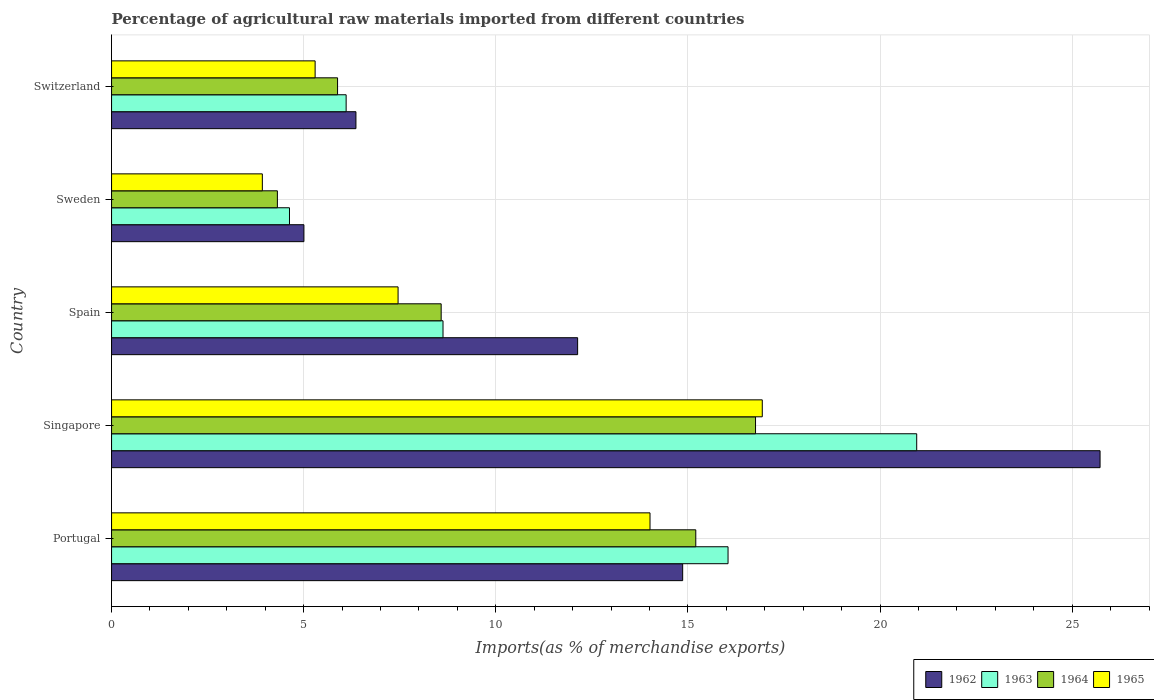In how many cases, is the number of bars for a given country not equal to the number of legend labels?
Ensure brevity in your answer.  0. What is the percentage of imports to different countries in 1965 in Portugal?
Provide a short and direct response. 14.01. Across all countries, what is the maximum percentage of imports to different countries in 1963?
Your response must be concise. 20.95. Across all countries, what is the minimum percentage of imports to different countries in 1965?
Offer a very short reply. 3.92. In which country was the percentage of imports to different countries in 1963 maximum?
Give a very brief answer. Singapore. In which country was the percentage of imports to different countries in 1963 minimum?
Your response must be concise. Sweden. What is the total percentage of imports to different countries in 1962 in the graph?
Make the answer very short. 64.08. What is the difference between the percentage of imports to different countries in 1963 in Portugal and that in Switzerland?
Offer a very short reply. 9.94. What is the difference between the percentage of imports to different countries in 1965 in Switzerland and the percentage of imports to different countries in 1963 in Portugal?
Your answer should be very brief. -10.75. What is the average percentage of imports to different countries in 1962 per country?
Provide a short and direct response. 12.82. What is the difference between the percentage of imports to different countries in 1962 and percentage of imports to different countries in 1963 in Spain?
Give a very brief answer. 3.5. In how many countries, is the percentage of imports to different countries in 1964 greater than 19 %?
Offer a very short reply. 0. What is the ratio of the percentage of imports to different countries in 1963 in Spain to that in Sweden?
Give a very brief answer. 1.86. Is the percentage of imports to different countries in 1965 in Sweden less than that in Switzerland?
Provide a succinct answer. Yes. Is the difference between the percentage of imports to different countries in 1962 in Portugal and Singapore greater than the difference between the percentage of imports to different countries in 1963 in Portugal and Singapore?
Your response must be concise. No. What is the difference between the highest and the second highest percentage of imports to different countries in 1965?
Your answer should be very brief. 2.92. What is the difference between the highest and the lowest percentage of imports to different countries in 1964?
Ensure brevity in your answer.  12.44. In how many countries, is the percentage of imports to different countries in 1964 greater than the average percentage of imports to different countries in 1964 taken over all countries?
Make the answer very short. 2. Is the sum of the percentage of imports to different countries in 1965 in Portugal and Singapore greater than the maximum percentage of imports to different countries in 1963 across all countries?
Your answer should be compact. Yes. What does the 3rd bar from the top in Spain represents?
Provide a succinct answer. 1963. What does the 4th bar from the bottom in Switzerland represents?
Give a very brief answer. 1965. Is it the case that in every country, the sum of the percentage of imports to different countries in 1964 and percentage of imports to different countries in 1962 is greater than the percentage of imports to different countries in 1965?
Your answer should be very brief. Yes. How many bars are there?
Make the answer very short. 20. How many countries are there in the graph?
Your answer should be very brief. 5. Are the values on the major ticks of X-axis written in scientific E-notation?
Give a very brief answer. No. Does the graph contain any zero values?
Your answer should be compact. No. How are the legend labels stacked?
Offer a very short reply. Horizontal. What is the title of the graph?
Ensure brevity in your answer.  Percentage of agricultural raw materials imported from different countries. Does "1985" appear as one of the legend labels in the graph?
Provide a short and direct response. No. What is the label or title of the X-axis?
Your answer should be very brief. Imports(as % of merchandise exports). What is the label or title of the Y-axis?
Keep it short and to the point. Country. What is the Imports(as % of merchandise exports) of 1962 in Portugal?
Offer a very short reply. 14.86. What is the Imports(as % of merchandise exports) of 1963 in Portugal?
Provide a short and direct response. 16.04. What is the Imports(as % of merchandise exports) of 1964 in Portugal?
Give a very brief answer. 15.2. What is the Imports(as % of merchandise exports) in 1965 in Portugal?
Your answer should be compact. 14.01. What is the Imports(as % of merchandise exports) of 1962 in Singapore?
Ensure brevity in your answer.  25.73. What is the Imports(as % of merchandise exports) in 1963 in Singapore?
Make the answer very short. 20.95. What is the Imports(as % of merchandise exports) in 1964 in Singapore?
Provide a succinct answer. 16.76. What is the Imports(as % of merchandise exports) in 1965 in Singapore?
Make the answer very short. 16.93. What is the Imports(as % of merchandise exports) of 1962 in Spain?
Your response must be concise. 12.13. What is the Imports(as % of merchandise exports) in 1963 in Spain?
Provide a succinct answer. 8.63. What is the Imports(as % of merchandise exports) in 1964 in Spain?
Your answer should be compact. 8.58. What is the Imports(as % of merchandise exports) in 1965 in Spain?
Make the answer very short. 7.46. What is the Imports(as % of merchandise exports) of 1962 in Sweden?
Offer a very short reply. 5.01. What is the Imports(as % of merchandise exports) in 1963 in Sweden?
Offer a very short reply. 4.63. What is the Imports(as % of merchandise exports) of 1964 in Sweden?
Offer a terse response. 4.32. What is the Imports(as % of merchandise exports) of 1965 in Sweden?
Offer a terse response. 3.92. What is the Imports(as % of merchandise exports) in 1962 in Switzerland?
Keep it short and to the point. 6.36. What is the Imports(as % of merchandise exports) in 1963 in Switzerland?
Provide a succinct answer. 6.1. What is the Imports(as % of merchandise exports) of 1964 in Switzerland?
Give a very brief answer. 5.88. What is the Imports(as % of merchandise exports) in 1965 in Switzerland?
Make the answer very short. 5.3. Across all countries, what is the maximum Imports(as % of merchandise exports) of 1962?
Your answer should be compact. 25.73. Across all countries, what is the maximum Imports(as % of merchandise exports) in 1963?
Give a very brief answer. 20.95. Across all countries, what is the maximum Imports(as % of merchandise exports) of 1964?
Offer a very short reply. 16.76. Across all countries, what is the maximum Imports(as % of merchandise exports) in 1965?
Make the answer very short. 16.93. Across all countries, what is the minimum Imports(as % of merchandise exports) in 1962?
Keep it short and to the point. 5.01. Across all countries, what is the minimum Imports(as % of merchandise exports) in 1963?
Keep it short and to the point. 4.63. Across all countries, what is the minimum Imports(as % of merchandise exports) of 1964?
Your answer should be very brief. 4.32. Across all countries, what is the minimum Imports(as % of merchandise exports) in 1965?
Your answer should be very brief. 3.92. What is the total Imports(as % of merchandise exports) of 1962 in the graph?
Make the answer very short. 64.08. What is the total Imports(as % of merchandise exports) in 1963 in the graph?
Offer a very short reply. 56.36. What is the total Imports(as % of merchandise exports) of 1964 in the graph?
Offer a terse response. 50.74. What is the total Imports(as % of merchandise exports) in 1965 in the graph?
Provide a succinct answer. 47.63. What is the difference between the Imports(as % of merchandise exports) of 1962 in Portugal and that in Singapore?
Provide a succinct answer. -10.86. What is the difference between the Imports(as % of merchandise exports) in 1963 in Portugal and that in Singapore?
Your response must be concise. -4.91. What is the difference between the Imports(as % of merchandise exports) in 1964 in Portugal and that in Singapore?
Provide a short and direct response. -1.55. What is the difference between the Imports(as % of merchandise exports) of 1965 in Portugal and that in Singapore?
Your answer should be compact. -2.92. What is the difference between the Imports(as % of merchandise exports) in 1962 in Portugal and that in Spain?
Provide a short and direct response. 2.73. What is the difference between the Imports(as % of merchandise exports) in 1963 in Portugal and that in Spain?
Ensure brevity in your answer.  7.42. What is the difference between the Imports(as % of merchandise exports) in 1964 in Portugal and that in Spain?
Keep it short and to the point. 6.63. What is the difference between the Imports(as % of merchandise exports) of 1965 in Portugal and that in Spain?
Your response must be concise. 6.56. What is the difference between the Imports(as % of merchandise exports) in 1962 in Portugal and that in Sweden?
Your answer should be very brief. 9.86. What is the difference between the Imports(as % of merchandise exports) in 1963 in Portugal and that in Sweden?
Give a very brief answer. 11.41. What is the difference between the Imports(as % of merchandise exports) of 1964 in Portugal and that in Sweden?
Your answer should be compact. 10.89. What is the difference between the Imports(as % of merchandise exports) in 1965 in Portugal and that in Sweden?
Offer a terse response. 10.09. What is the difference between the Imports(as % of merchandise exports) of 1962 in Portugal and that in Switzerland?
Provide a short and direct response. 8.5. What is the difference between the Imports(as % of merchandise exports) of 1963 in Portugal and that in Switzerland?
Your answer should be compact. 9.94. What is the difference between the Imports(as % of merchandise exports) in 1964 in Portugal and that in Switzerland?
Offer a terse response. 9.32. What is the difference between the Imports(as % of merchandise exports) of 1965 in Portugal and that in Switzerland?
Give a very brief answer. 8.72. What is the difference between the Imports(as % of merchandise exports) in 1962 in Singapore and that in Spain?
Provide a short and direct response. 13.6. What is the difference between the Imports(as % of merchandise exports) in 1963 in Singapore and that in Spain?
Your answer should be compact. 12.33. What is the difference between the Imports(as % of merchandise exports) of 1964 in Singapore and that in Spain?
Your answer should be compact. 8.18. What is the difference between the Imports(as % of merchandise exports) in 1965 in Singapore and that in Spain?
Keep it short and to the point. 9.48. What is the difference between the Imports(as % of merchandise exports) in 1962 in Singapore and that in Sweden?
Keep it short and to the point. 20.72. What is the difference between the Imports(as % of merchandise exports) in 1963 in Singapore and that in Sweden?
Make the answer very short. 16.32. What is the difference between the Imports(as % of merchandise exports) of 1964 in Singapore and that in Sweden?
Provide a succinct answer. 12.44. What is the difference between the Imports(as % of merchandise exports) of 1965 in Singapore and that in Sweden?
Make the answer very short. 13.01. What is the difference between the Imports(as % of merchandise exports) of 1962 in Singapore and that in Switzerland?
Make the answer very short. 19.37. What is the difference between the Imports(as % of merchandise exports) in 1963 in Singapore and that in Switzerland?
Offer a terse response. 14.85. What is the difference between the Imports(as % of merchandise exports) in 1964 in Singapore and that in Switzerland?
Ensure brevity in your answer.  10.88. What is the difference between the Imports(as % of merchandise exports) in 1965 in Singapore and that in Switzerland?
Keep it short and to the point. 11.64. What is the difference between the Imports(as % of merchandise exports) of 1962 in Spain and that in Sweden?
Ensure brevity in your answer.  7.12. What is the difference between the Imports(as % of merchandise exports) of 1963 in Spain and that in Sweden?
Offer a very short reply. 4. What is the difference between the Imports(as % of merchandise exports) in 1964 in Spain and that in Sweden?
Ensure brevity in your answer.  4.26. What is the difference between the Imports(as % of merchandise exports) in 1965 in Spain and that in Sweden?
Your answer should be very brief. 3.53. What is the difference between the Imports(as % of merchandise exports) of 1962 in Spain and that in Switzerland?
Keep it short and to the point. 5.77. What is the difference between the Imports(as % of merchandise exports) of 1963 in Spain and that in Switzerland?
Provide a succinct answer. 2.52. What is the difference between the Imports(as % of merchandise exports) in 1964 in Spain and that in Switzerland?
Make the answer very short. 2.7. What is the difference between the Imports(as % of merchandise exports) of 1965 in Spain and that in Switzerland?
Make the answer very short. 2.16. What is the difference between the Imports(as % of merchandise exports) of 1962 in Sweden and that in Switzerland?
Offer a very short reply. -1.35. What is the difference between the Imports(as % of merchandise exports) of 1963 in Sweden and that in Switzerland?
Your answer should be compact. -1.47. What is the difference between the Imports(as % of merchandise exports) of 1964 in Sweden and that in Switzerland?
Your response must be concise. -1.57. What is the difference between the Imports(as % of merchandise exports) of 1965 in Sweden and that in Switzerland?
Offer a very short reply. -1.37. What is the difference between the Imports(as % of merchandise exports) of 1962 in Portugal and the Imports(as % of merchandise exports) of 1963 in Singapore?
Make the answer very short. -6.09. What is the difference between the Imports(as % of merchandise exports) of 1962 in Portugal and the Imports(as % of merchandise exports) of 1964 in Singapore?
Your response must be concise. -1.9. What is the difference between the Imports(as % of merchandise exports) of 1962 in Portugal and the Imports(as % of merchandise exports) of 1965 in Singapore?
Ensure brevity in your answer.  -2.07. What is the difference between the Imports(as % of merchandise exports) in 1963 in Portugal and the Imports(as % of merchandise exports) in 1964 in Singapore?
Your answer should be compact. -0.72. What is the difference between the Imports(as % of merchandise exports) in 1963 in Portugal and the Imports(as % of merchandise exports) in 1965 in Singapore?
Your answer should be very brief. -0.89. What is the difference between the Imports(as % of merchandise exports) of 1964 in Portugal and the Imports(as % of merchandise exports) of 1965 in Singapore?
Give a very brief answer. -1.73. What is the difference between the Imports(as % of merchandise exports) in 1962 in Portugal and the Imports(as % of merchandise exports) in 1963 in Spain?
Offer a very short reply. 6.24. What is the difference between the Imports(as % of merchandise exports) in 1962 in Portugal and the Imports(as % of merchandise exports) in 1964 in Spain?
Keep it short and to the point. 6.28. What is the difference between the Imports(as % of merchandise exports) of 1962 in Portugal and the Imports(as % of merchandise exports) of 1965 in Spain?
Provide a succinct answer. 7.41. What is the difference between the Imports(as % of merchandise exports) of 1963 in Portugal and the Imports(as % of merchandise exports) of 1964 in Spain?
Ensure brevity in your answer.  7.47. What is the difference between the Imports(as % of merchandise exports) in 1963 in Portugal and the Imports(as % of merchandise exports) in 1965 in Spain?
Your response must be concise. 8.59. What is the difference between the Imports(as % of merchandise exports) in 1964 in Portugal and the Imports(as % of merchandise exports) in 1965 in Spain?
Your answer should be compact. 7.75. What is the difference between the Imports(as % of merchandise exports) in 1962 in Portugal and the Imports(as % of merchandise exports) in 1963 in Sweden?
Provide a succinct answer. 10.23. What is the difference between the Imports(as % of merchandise exports) of 1962 in Portugal and the Imports(as % of merchandise exports) of 1964 in Sweden?
Offer a terse response. 10.55. What is the difference between the Imports(as % of merchandise exports) of 1962 in Portugal and the Imports(as % of merchandise exports) of 1965 in Sweden?
Offer a very short reply. 10.94. What is the difference between the Imports(as % of merchandise exports) in 1963 in Portugal and the Imports(as % of merchandise exports) in 1964 in Sweden?
Offer a very short reply. 11.73. What is the difference between the Imports(as % of merchandise exports) of 1963 in Portugal and the Imports(as % of merchandise exports) of 1965 in Sweden?
Provide a short and direct response. 12.12. What is the difference between the Imports(as % of merchandise exports) of 1964 in Portugal and the Imports(as % of merchandise exports) of 1965 in Sweden?
Give a very brief answer. 11.28. What is the difference between the Imports(as % of merchandise exports) of 1962 in Portugal and the Imports(as % of merchandise exports) of 1963 in Switzerland?
Your answer should be compact. 8.76. What is the difference between the Imports(as % of merchandise exports) of 1962 in Portugal and the Imports(as % of merchandise exports) of 1964 in Switzerland?
Ensure brevity in your answer.  8.98. What is the difference between the Imports(as % of merchandise exports) in 1962 in Portugal and the Imports(as % of merchandise exports) in 1965 in Switzerland?
Make the answer very short. 9.57. What is the difference between the Imports(as % of merchandise exports) of 1963 in Portugal and the Imports(as % of merchandise exports) of 1964 in Switzerland?
Your response must be concise. 10.16. What is the difference between the Imports(as % of merchandise exports) of 1963 in Portugal and the Imports(as % of merchandise exports) of 1965 in Switzerland?
Make the answer very short. 10.75. What is the difference between the Imports(as % of merchandise exports) in 1964 in Portugal and the Imports(as % of merchandise exports) in 1965 in Switzerland?
Provide a succinct answer. 9.91. What is the difference between the Imports(as % of merchandise exports) of 1962 in Singapore and the Imports(as % of merchandise exports) of 1963 in Spain?
Keep it short and to the point. 17.1. What is the difference between the Imports(as % of merchandise exports) in 1962 in Singapore and the Imports(as % of merchandise exports) in 1964 in Spain?
Give a very brief answer. 17.15. What is the difference between the Imports(as % of merchandise exports) of 1962 in Singapore and the Imports(as % of merchandise exports) of 1965 in Spain?
Ensure brevity in your answer.  18.27. What is the difference between the Imports(as % of merchandise exports) of 1963 in Singapore and the Imports(as % of merchandise exports) of 1964 in Spain?
Your response must be concise. 12.38. What is the difference between the Imports(as % of merchandise exports) of 1963 in Singapore and the Imports(as % of merchandise exports) of 1965 in Spain?
Give a very brief answer. 13.5. What is the difference between the Imports(as % of merchandise exports) in 1964 in Singapore and the Imports(as % of merchandise exports) in 1965 in Spain?
Make the answer very short. 9.3. What is the difference between the Imports(as % of merchandise exports) of 1962 in Singapore and the Imports(as % of merchandise exports) of 1963 in Sweden?
Your answer should be very brief. 21.09. What is the difference between the Imports(as % of merchandise exports) of 1962 in Singapore and the Imports(as % of merchandise exports) of 1964 in Sweden?
Offer a terse response. 21.41. What is the difference between the Imports(as % of merchandise exports) in 1962 in Singapore and the Imports(as % of merchandise exports) in 1965 in Sweden?
Give a very brief answer. 21.8. What is the difference between the Imports(as % of merchandise exports) in 1963 in Singapore and the Imports(as % of merchandise exports) in 1964 in Sweden?
Offer a terse response. 16.64. What is the difference between the Imports(as % of merchandise exports) of 1963 in Singapore and the Imports(as % of merchandise exports) of 1965 in Sweden?
Your response must be concise. 17.03. What is the difference between the Imports(as % of merchandise exports) of 1964 in Singapore and the Imports(as % of merchandise exports) of 1965 in Sweden?
Your response must be concise. 12.83. What is the difference between the Imports(as % of merchandise exports) in 1962 in Singapore and the Imports(as % of merchandise exports) in 1963 in Switzerland?
Give a very brief answer. 19.62. What is the difference between the Imports(as % of merchandise exports) of 1962 in Singapore and the Imports(as % of merchandise exports) of 1964 in Switzerland?
Your answer should be compact. 19.84. What is the difference between the Imports(as % of merchandise exports) in 1962 in Singapore and the Imports(as % of merchandise exports) in 1965 in Switzerland?
Your response must be concise. 20.43. What is the difference between the Imports(as % of merchandise exports) of 1963 in Singapore and the Imports(as % of merchandise exports) of 1964 in Switzerland?
Give a very brief answer. 15.07. What is the difference between the Imports(as % of merchandise exports) of 1963 in Singapore and the Imports(as % of merchandise exports) of 1965 in Switzerland?
Your answer should be compact. 15.66. What is the difference between the Imports(as % of merchandise exports) in 1964 in Singapore and the Imports(as % of merchandise exports) in 1965 in Switzerland?
Provide a short and direct response. 11.46. What is the difference between the Imports(as % of merchandise exports) of 1962 in Spain and the Imports(as % of merchandise exports) of 1963 in Sweden?
Give a very brief answer. 7.5. What is the difference between the Imports(as % of merchandise exports) of 1962 in Spain and the Imports(as % of merchandise exports) of 1964 in Sweden?
Provide a short and direct response. 7.81. What is the difference between the Imports(as % of merchandise exports) in 1962 in Spain and the Imports(as % of merchandise exports) in 1965 in Sweden?
Make the answer very short. 8.21. What is the difference between the Imports(as % of merchandise exports) of 1963 in Spain and the Imports(as % of merchandise exports) of 1964 in Sweden?
Provide a short and direct response. 4.31. What is the difference between the Imports(as % of merchandise exports) in 1963 in Spain and the Imports(as % of merchandise exports) in 1965 in Sweden?
Provide a succinct answer. 4.7. What is the difference between the Imports(as % of merchandise exports) in 1964 in Spain and the Imports(as % of merchandise exports) in 1965 in Sweden?
Give a very brief answer. 4.65. What is the difference between the Imports(as % of merchandise exports) in 1962 in Spain and the Imports(as % of merchandise exports) in 1963 in Switzerland?
Offer a terse response. 6.02. What is the difference between the Imports(as % of merchandise exports) in 1962 in Spain and the Imports(as % of merchandise exports) in 1964 in Switzerland?
Your answer should be compact. 6.25. What is the difference between the Imports(as % of merchandise exports) of 1962 in Spain and the Imports(as % of merchandise exports) of 1965 in Switzerland?
Provide a succinct answer. 6.83. What is the difference between the Imports(as % of merchandise exports) in 1963 in Spain and the Imports(as % of merchandise exports) in 1964 in Switzerland?
Give a very brief answer. 2.74. What is the difference between the Imports(as % of merchandise exports) of 1963 in Spain and the Imports(as % of merchandise exports) of 1965 in Switzerland?
Offer a terse response. 3.33. What is the difference between the Imports(as % of merchandise exports) in 1964 in Spain and the Imports(as % of merchandise exports) in 1965 in Switzerland?
Your answer should be compact. 3.28. What is the difference between the Imports(as % of merchandise exports) in 1962 in Sweden and the Imports(as % of merchandise exports) in 1963 in Switzerland?
Offer a very short reply. -1.1. What is the difference between the Imports(as % of merchandise exports) in 1962 in Sweden and the Imports(as % of merchandise exports) in 1964 in Switzerland?
Your answer should be very brief. -0.88. What is the difference between the Imports(as % of merchandise exports) in 1962 in Sweden and the Imports(as % of merchandise exports) in 1965 in Switzerland?
Offer a terse response. -0.29. What is the difference between the Imports(as % of merchandise exports) in 1963 in Sweden and the Imports(as % of merchandise exports) in 1964 in Switzerland?
Offer a very short reply. -1.25. What is the difference between the Imports(as % of merchandise exports) in 1963 in Sweden and the Imports(as % of merchandise exports) in 1965 in Switzerland?
Offer a terse response. -0.67. What is the difference between the Imports(as % of merchandise exports) in 1964 in Sweden and the Imports(as % of merchandise exports) in 1965 in Switzerland?
Your answer should be compact. -0.98. What is the average Imports(as % of merchandise exports) of 1962 per country?
Provide a succinct answer. 12.82. What is the average Imports(as % of merchandise exports) of 1963 per country?
Provide a succinct answer. 11.27. What is the average Imports(as % of merchandise exports) in 1964 per country?
Offer a terse response. 10.15. What is the average Imports(as % of merchandise exports) of 1965 per country?
Keep it short and to the point. 9.53. What is the difference between the Imports(as % of merchandise exports) in 1962 and Imports(as % of merchandise exports) in 1963 in Portugal?
Your answer should be compact. -1.18. What is the difference between the Imports(as % of merchandise exports) in 1962 and Imports(as % of merchandise exports) in 1964 in Portugal?
Give a very brief answer. -0.34. What is the difference between the Imports(as % of merchandise exports) of 1962 and Imports(as % of merchandise exports) of 1965 in Portugal?
Your answer should be very brief. 0.85. What is the difference between the Imports(as % of merchandise exports) in 1963 and Imports(as % of merchandise exports) in 1964 in Portugal?
Provide a succinct answer. 0.84. What is the difference between the Imports(as % of merchandise exports) of 1963 and Imports(as % of merchandise exports) of 1965 in Portugal?
Keep it short and to the point. 2.03. What is the difference between the Imports(as % of merchandise exports) of 1964 and Imports(as % of merchandise exports) of 1965 in Portugal?
Your answer should be compact. 1.19. What is the difference between the Imports(as % of merchandise exports) in 1962 and Imports(as % of merchandise exports) in 1963 in Singapore?
Offer a terse response. 4.77. What is the difference between the Imports(as % of merchandise exports) of 1962 and Imports(as % of merchandise exports) of 1964 in Singapore?
Keep it short and to the point. 8.97. What is the difference between the Imports(as % of merchandise exports) of 1962 and Imports(as % of merchandise exports) of 1965 in Singapore?
Your answer should be very brief. 8.79. What is the difference between the Imports(as % of merchandise exports) in 1963 and Imports(as % of merchandise exports) in 1964 in Singapore?
Your answer should be compact. 4.19. What is the difference between the Imports(as % of merchandise exports) of 1963 and Imports(as % of merchandise exports) of 1965 in Singapore?
Provide a short and direct response. 4.02. What is the difference between the Imports(as % of merchandise exports) of 1964 and Imports(as % of merchandise exports) of 1965 in Singapore?
Give a very brief answer. -0.18. What is the difference between the Imports(as % of merchandise exports) in 1962 and Imports(as % of merchandise exports) in 1963 in Spain?
Provide a succinct answer. 3.5. What is the difference between the Imports(as % of merchandise exports) of 1962 and Imports(as % of merchandise exports) of 1964 in Spain?
Offer a terse response. 3.55. What is the difference between the Imports(as % of merchandise exports) of 1962 and Imports(as % of merchandise exports) of 1965 in Spain?
Make the answer very short. 4.67. What is the difference between the Imports(as % of merchandise exports) in 1963 and Imports(as % of merchandise exports) in 1964 in Spain?
Ensure brevity in your answer.  0.05. What is the difference between the Imports(as % of merchandise exports) of 1963 and Imports(as % of merchandise exports) of 1965 in Spain?
Give a very brief answer. 1.17. What is the difference between the Imports(as % of merchandise exports) in 1964 and Imports(as % of merchandise exports) in 1965 in Spain?
Provide a succinct answer. 1.12. What is the difference between the Imports(as % of merchandise exports) in 1962 and Imports(as % of merchandise exports) in 1963 in Sweden?
Give a very brief answer. 0.38. What is the difference between the Imports(as % of merchandise exports) of 1962 and Imports(as % of merchandise exports) of 1964 in Sweden?
Your answer should be compact. 0.69. What is the difference between the Imports(as % of merchandise exports) in 1962 and Imports(as % of merchandise exports) in 1965 in Sweden?
Offer a very short reply. 1.08. What is the difference between the Imports(as % of merchandise exports) in 1963 and Imports(as % of merchandise exports) in 1964 in Sweden?
Your response must be concise. 0.31. What is the difference between the Imports(as % of merchandise exports) in 1963 and Imports(as % of merchandise exports) in 1965 in Sweden?
Keep it short and to the point. 0.71. What is the difference between the Imports(as % of merchandise exports) in 1964 and Imports(as % of merchandise exports) in 1965 in Sweden?
Give a very brief answer. 0.39. What is the difference between the Imports(as % of merchandise exports) in 1962 and Imports(as % of merchandise exports) in 1963 in Switzerland?
Offer a very short reply. 0.26. What is the difference between the Imports(as % of merchandise exports) of 1962 and Imports(as % of merchandise exports) of 1964 in Switzerland?
Your answer should be very brief. 0.48. What is the difference between the Imports(as % of merchandise exports) of 1962 and Imports(as % of merchandise exports) of 1965 in Switzerland?
Keep it short and to the point. 1.06. What is the difference between the Imports(as % of merchandise exports) of 1963 and Imports(as % of merchandise exports) of 1964 in Switzerland?
Make the answer very short. 0.22. What is the difference between the Imports(as % of merchandise exports) of 1963 and Imports(as % of merchandise exports) of 1965 in Switzerland?
Offer a terse response. 0.81. What is the difference between the Imports(as % of merchandise exports) of 1964 and Imports(as % of merchandise exports) of 1965 in Switzerland?
Your answer should be compact. 0.58. What is the ratio of the Imports(as % of merchandise exports) of 1962 in Portugal to that in Singapore?
Give a very brief answer. 0.58. What is the ratio of the Imports(as % of merchandise exports) of 1963 in Portugal to that in Singapore?
Provide a succinct answer. 0.77. What is the ratio of the Imports(as % of merchandise exports) of 1964 in Portugal to that in Singapore?
Ensure brevity in your answer.  0.91. What is the ratio of the Imports(as % of merchandise exports) of 1965 in Portugal to that in Singapore?
Provide a succinct answer. 0.83. What is the ratio of the Imports(as % of merchandise exports) of 1962 in Portugal to that in Spain?
Provide a succinct answer. 1.23. What is the ratio of the Imports(as % of merchandise exports) in 1963 in Portugal to that in Spain?
Ensure brevity in your answer.  1.86. What is the ratio of the Imports(as % of merchandise exports) in 1964 in Portugal to that in Spain?
Keep it short and to the point. 1.77. What is the ratio of the Imports(as % of merchandise exports) in 1965 in Portugal to that in Spain?
Make the answer very short. 1.88. What is the ratio of the Imports(as % of merchandise exports) of 1962 in Portugal to that in Sweden?
Your response must be concise. 2.97. What is the ratio of the Imports(as % of merchandise exports) of 1963 in Portugal to that in Sweden?
Provide a short and direct response. 3.46. What is the ratio of the Imports(as % of merchandise exports) of 1964 in Portugal to that in Sweden?
Provide a succinct answer. 3.52. What is the ratio of the Imports(as % of merchandise exports) in 1965 in Portugal to that in Sweden?
Ensure brevity in your answer.  3.57. What is the ratio of the Imports(as % of merchandise exports) in 1962 in Portugal to that in Switzerland?
Your answer should be very brief. 2.34. What is the ratio of the Imports(as % of merchandise exports) of 1963 in Portugal to that in Switzerland?
Give a very brief answer. 2.63. What is the ratio of the Imports(as % of merchandise exports) of 1964 in Portugal to that in Switzerland?
Give a very brief answer. 2.58. What is the ratio of the Imports(as % of merchandise exports) in 1965 in Portugal to that in Switzerland?
Offer a terse response. 2.65. What is the ratio of the Imports(as % of merchandise exports) in 1962 in Singapore to that in Spain?
Provide a succinct answer. 2.12. What is the ratio of the Imports(as % of merchandise exports) of 1963 in Singapore to that in Spain?
Give a very brief answer. 2.43. What is the ratio of the Imports(as % of merchandise exports) in 1964 in Singapore to that in Spain?
Make the answer very short. 1.95. What is the ratio of the Imports(as % of merchandise exports) in 1965 in Singapore to that in Spain?
Your answer should be compact. 2.27. What is the ratio of the Imports(as % of merchandise exports) in 1962 in Singapore to that in Sweden?
Your answer should be very brief. 5.14. What is the ratio of the Imports(as % of merchandise exports) of 1963 in Singapore to that in Sweden?
Ensure brevity in your answer.  4.53. What is the ratio of the Imports(as % of merchandise exports) in 1964 in Singapore to that in Sweden?
Ensure brevity in your answer.  3.88. What is the ratio of the Imports(as % of merchandise exports) of 1965 in Singapore to that in Sweden?
Keep it short and to the point. 4.32. What is the ratio of the Imports(as % of merchandise exports) of 1962 in Singapore to that in Switzerland?
Your answer should be compact. 4.04. What is the ratio of the Imports(as % of merchandise exports) of 1963 in Singapore to that in Switzerland?
Keep it short and to the point. 3.43. What is the ratio of the Imports(as % of merchandise exports) in 1964 in Singapore to that in Switzerland?
Keep it short and to the point. 2.85. What is the ratio of the Imports(as % of merchandise exports) of 1965 in Singapore to that in Switzerland?
Ensure brevity in your answer.  3.2. What is the ratio of the Imports(as % of merchandise exports) in 1962 in Spain to that in Sweden?
Keep it short and to the point. 2.42. What is the ratio of the Imports(as % of merchandise exports) of 1963 in Spain to that in Sweden?
Your response must be concise. 1.86. What is the ratio of the Imports(as % of merchandise exports) in 1964 in Spain to that in Sweden?
Make the answer very short. 1.99. What is the ratio of the Imports(as % of merchandise exports) of 1965 in Spain to that in Sweden?
Provide a short and direct response. 1.9. What is the ratio of the Imports(as % of merchandise exports) in 1962 in Spain to that in Switzerland?
Provide a succinct answer. 1.91. What is the ratio of the Imports(as % of merchandise exports) of 1963 in Spain to that in Switzerland?
Provide a succinct answer. 1.41. What is the ratio of the Imports(as % of merchandise exports) of 1964 in Spain to that in Switzerland?
Your response must be concise. 1.46. What is the ratio of the Imports(as % of merchandise exports) of 1965 in Spain to that in Switzerland?
Give a very brief answer. 1.41. What is the ratio of the Imports(as % of merchandise exports) in 1962 in Sweden to that in Switzerland?
Your answer should be very brief. 0.79. What is the ratio of the Imports(as % of merchandise exports) in 1963 in Sweden to that in Switzerland?
Offer a very short reply. 0.76. What is the ratio of the Imports(as % of merchandise exports) of 1964 in Sweden to that in Switzerland?
Your answer should be very brief. 0.73. What is the ratio of the Imports(as % of merchandise exports) in 1965 in Sweden to that in Switzerland?
Provide a succinct answer. 0.74. What is the difference between the highest and the second highest Imports(as % of merchandise exports) in 1962?
Provide a short and direct response. 10.86. What is the difference between the highest and the second highest Imports(as % of merchandise exports) in 1963?
Keep it short and to the point. 4.91. What is the difference between the highest and the second highest Imports(as % of merchandise exports) of 1964?
Provide a short and direct response. 1.55. What is the difference between the highest and the second highest Imports(as % of merchandise exports) of 1965?
Offer a very short reply. 2.92. What is the difference between the highest and the lowest Imports(as % of merchandise exports) in 1962?
Your answer should be compact. 20.72. What is the difference between the highest and the lowest Imports(as % of merchandise exports) in 1963?
Provide a short and direct response. 16.32. What is the difference between the highest and the lowest Imports(as % of merchandise exports) in 1964?
Offer a terse response. 12.44. What is the difference between the highest and the lowest Imports(as % of merchandise exports) in 1965?
Your response must be concise. 13.01. 